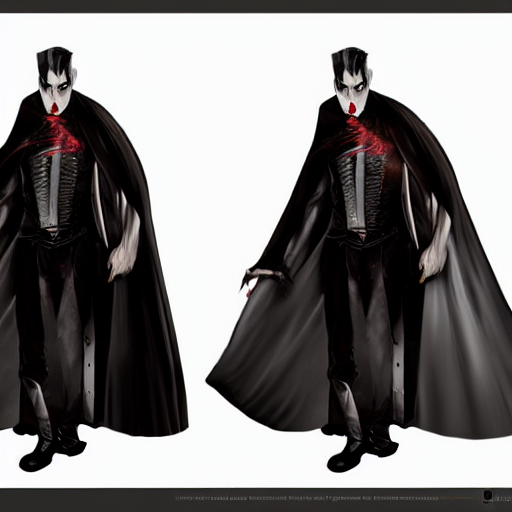What style and era does the character's costume suggest? The character's costume features a traditional, gothic aesthetic commonly associated with the Victorian era. Elements such as the high-collared cape, the ornate vest, and formal trousers indicate a style that is both timeless and reminiscent of 19th-century fashion, typically worn by figures of mystery and nobility in gothic literature and cinema. 